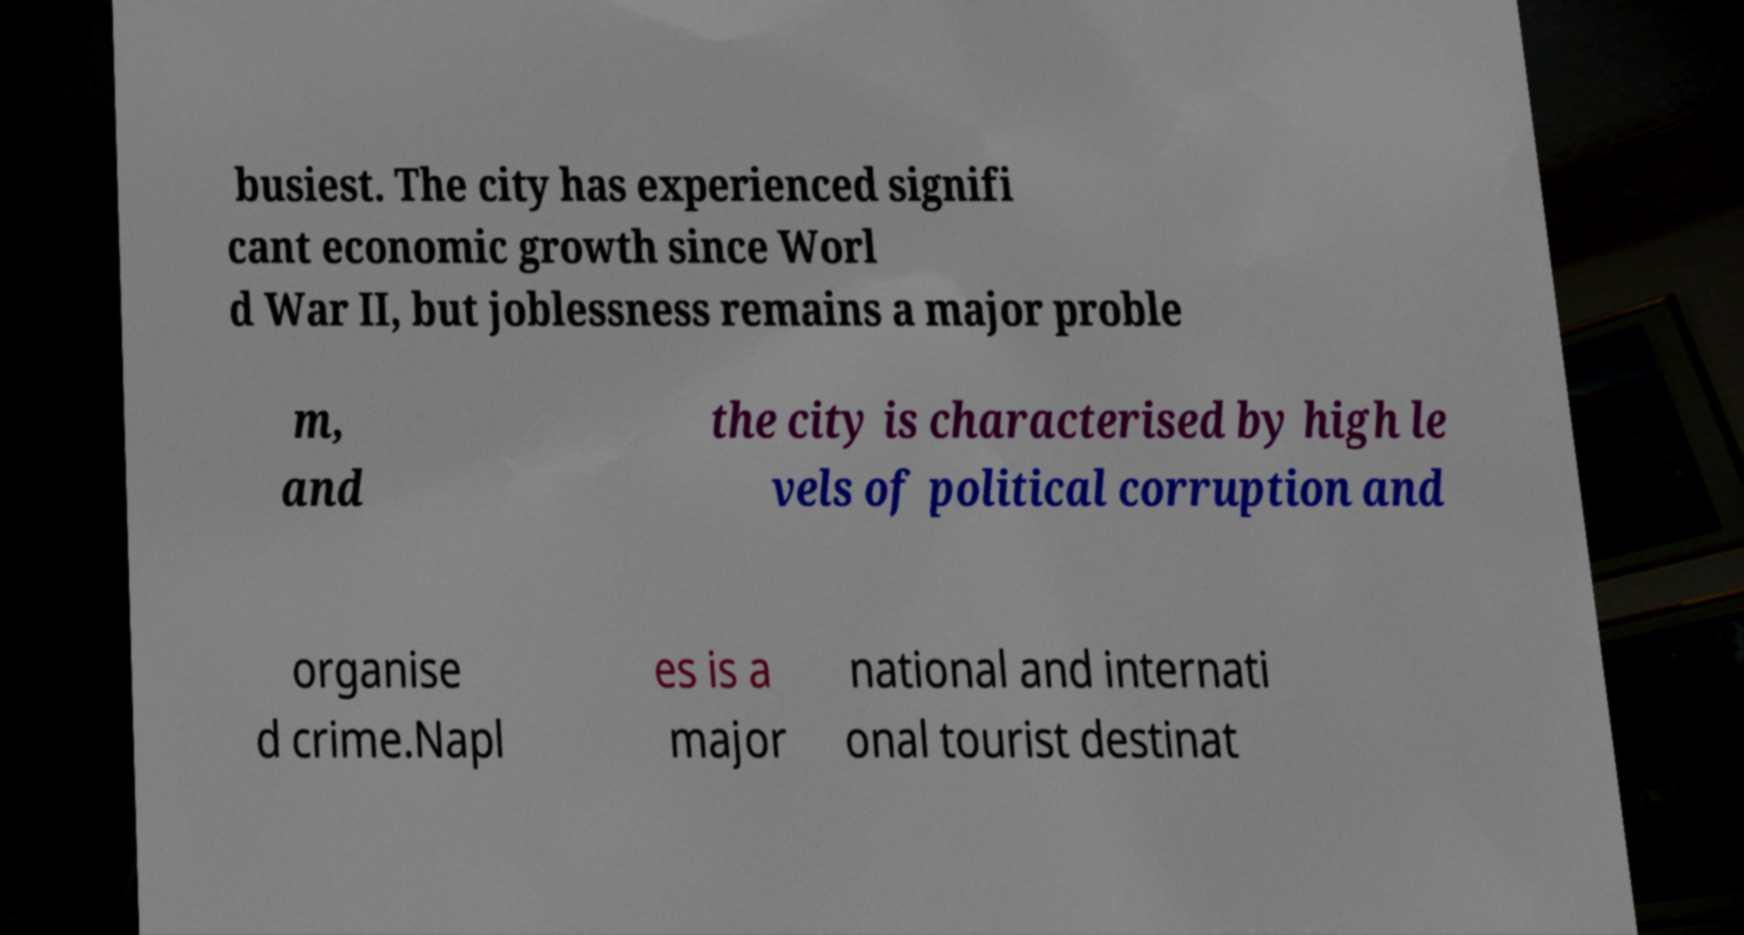For documentation purposes, I need the text within this image transcribed. Could you provide that? busiest. The city has experienced signifi cant economic growth since Worl d War II, but joblessness remains a major proble m, and the city is characterised by high le vels of political corruption and organise d crime.Napl es is a major national and internati onal tourist destinat 